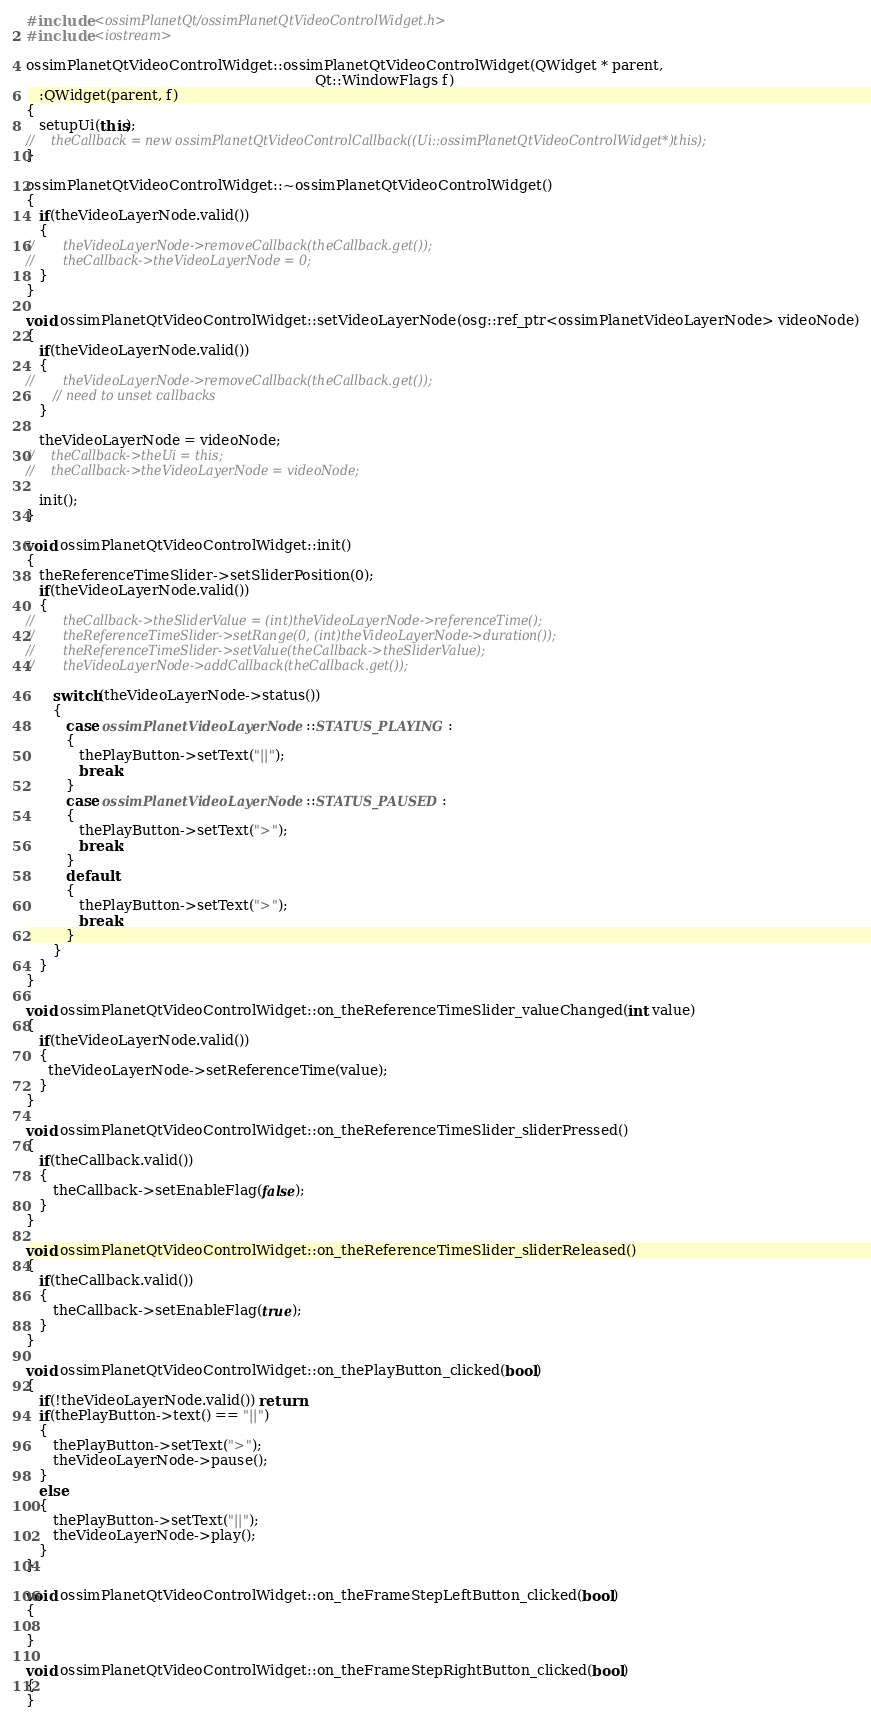Convert code to text. <code><loc_0><loc_0><loc_500><loc_500><_C++_>#include <ossimPlanetQt/ossimPlanetQtVideoControlWidget.h>
#include <iostream>

ossimPlanetQtVideoControlWidget::ossimPlanetQtVideoControlWidget(QWidget * parent,
                                                                 Qt::WindowFlags f)
   :QWidget(parent, f)
{
   setupUi(this);
//    theCallback = new ossimPlanetQtVideoControlCallback((Ui::ossimPlanetQtVideoControlWidget*)this);
}

ossimPlanetQtVideoControlWidget::~ossimPlanetQtVideoControlWidget()
{
   if(theVideoLayerNode.valid())
   {
//       theVideoLayerNode->removeCallback(theCallback.get());
//       theCallback->theVideoLayerNode = 0;
   }
}

void ossimPlanetQtVideoControlWidget::setVideoLayerNode(osg::ref_ptr<ossimPlanetVideoLayerNode> videoNode)
{
   if(theVideoLayerNode.valid())
   {
//       theVideoLayerNode->removeCallback(theCallback.get());
      // need to unset callbacks
   }
   
   theVideoLayerNode = videoNode;
//    theCallback->theUi = this;
//    theCallback->theVideoLayerNode = videoNode;
   
   init();
}

void ossimPlanetQtVideoControlWidget::init()
{
   theReferenceTimeSlider->setSliderPosition(0);
   if(theVideoLayerNode.valid())
   {
//       theCallback->theSliderValue = (int)theVideoLayerNode->referenceTime();
//       theReferenceTimeSlider->setRange(0, (int)theVideoLayerNode->duration());
//       theReferenceTimeSlider->setValue(theCallback->theSliderValue);
//       theVideoLayerNode->addCallback(theCallback.get());

      switch(theVideoLayerNode->status())
      {
         case ossimPlanetVideoLayerNode::STATUS_PLAYING:
         {
            thePlayButton->setText("||");  
            break;
         }
         case ossimPlanetVideoLayerNode::STATUS_PAUSED:
         {
            thePlayButton->setText(">");
            break;
         }
         default:
         {
            thePlayButton->setText(">");
            break;
         }
      }
   }
}

void ossimPlanetQtVideoControlWidget::on_theReferenceTimeSlider_valueChanged(int value)
{
   if(theVideoLayerNode.valid())
   {
     theVideoLayerNode->setReferenceTime(value);
   }
}

void ossimPlanetQtVideoControlWidget::on_theReferenceTimeSlider_sliderPressed()
{
   if(theCallback.valid())
   {
      theCallback->setEnableFlag(false);
   }
}

void ossimPlanetQtVideoControlWidget::on_theReferenceTimeSlider_sliderReleased()
{
   if(theCallback.valid())
   {
      theCallback->setEnableFlag(true);
   }
}

void ossimPlanetQtVideoControlWidget::on_thePlayButton_clicked(bool)
{
   if(!theVideoLayerNode.valid()) return;
   if(thePlayButton->text() == "||")
   {
      thePlayButton->setText(">");
      theVideoLayerNode->pause();
   }
   else
   {
      thePlayButton->setText("||");
      theVideoLayerNode->play();
   }
}

void ossimPlanetQtVideoControlWidget::on_theFrameStepLeftButton_clicked(bool)
{
   
}

void ossimPlanetQtVideoControlWidget::on_theFrameStepRightButton_clicked(bool)
{
}
</code> 